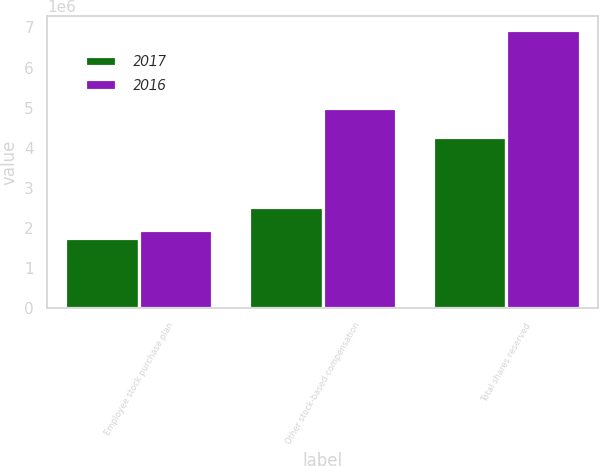Convert chart. <chart><loc_0><loc_0><loc_500><loc_500><stacked_bar_chart><ecel><fcel>Employee stock purchase plan<fcel>Other stock-based compensation<fcel>Total shares reserved<nl><fcel>2017<fcel>1.74594e+06<fcel>2.52634e+06<fcel>4.27228e+06<nl><fcel>2016<fcel>1.93609e+06<fcel>4.99898e+06<fcel>6.93508e+06<nl></chart> 